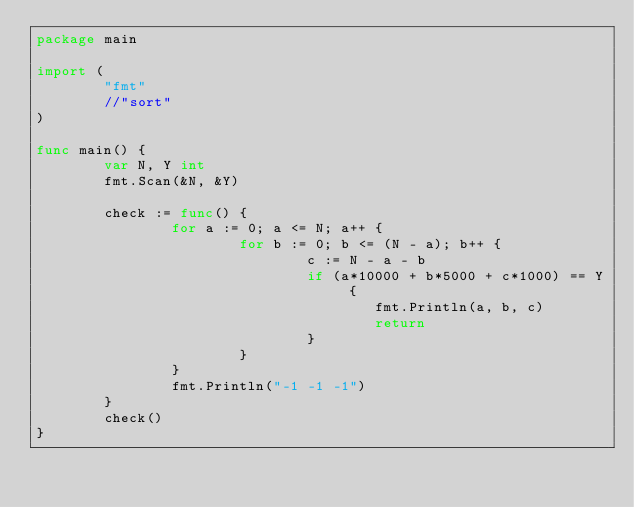<code> <loc_0><loc_0><loc_500><loc_500><_Go_>package main

import (
        "fmt"
        //"sort"
)

func main() {
        var N, Y int
        fmt.Scan(&N, &Y)

        check := func() {
                for a := 0; a <= N; a++ {
                        for b := 0; b <= (N - a); b++ {
                                c := N - a - b
                                if (a*10000 + b*5000 + c*1000) == Y {
                                        fmt.Println(a, b, c)
                                        return
                                }
                        }
                }
                fmt.Println("-1 -1 -1")
        }
        check()
}
</code> 